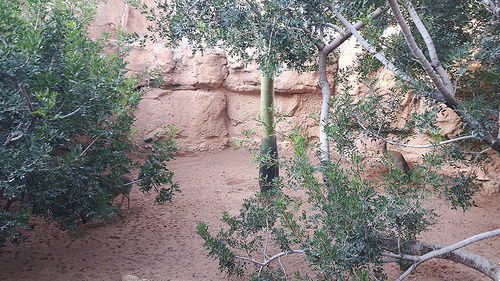<image>
Is the branch under the ground? No. The branch is not positioned under the ground. The vertical relationship between these objects is different. 